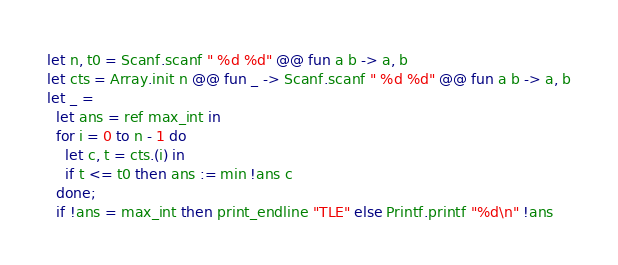<code> <loc_0><loc_0><loc_500><loc_500><_OCaml_>let n, t0 = Scanf.scanf " %d %d" @@ fun a b -> a, b
let cts = Array.init n @@ fun _ -> Scanf.scanf " %d %d" @@ fun a b -> a, b
let _ =
  let ans = ref max_int in
  for i = 0 to n - 1 do
    let c, t = cts.(i) in
    if t <= t0 then ans := min !ans c
  done;
  if !ans = max_int then print_endline "TLE" else Printf.printf "%d\n" !ans</code> 